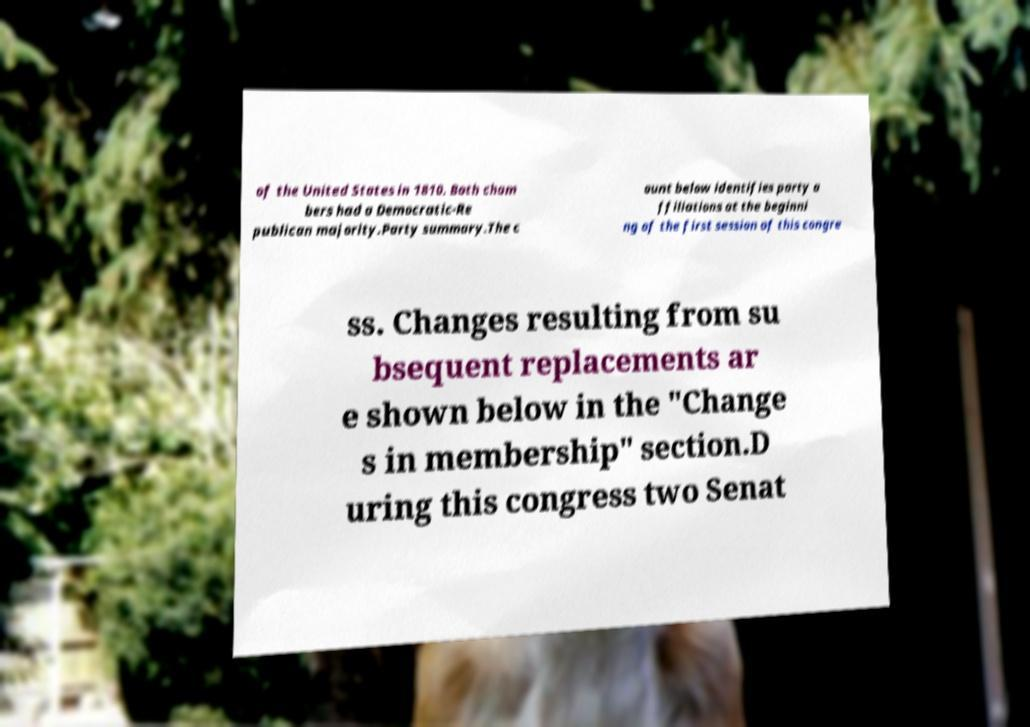Please read and relay the text visible in this image. What does it say? of the United States in 1810. Both cham bers had a Democratic-Re publican majority.Party summary.The c ount below identifies party a ffiliations at the beginni ng of the first session of this congre ss. Changes resulting from su bsequent replacements ar e shown below in the "Change s in membership" section.D uring this congress two Senat 